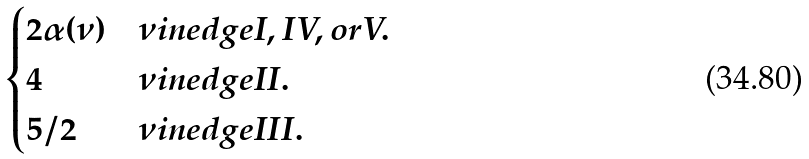Convert formula to latex. <formula><loc_0><loc_0><loc_500><loc_500>\begin{cases} 2 \alpha ( \nu ) & \nu i n e d g e I , I V , o r V . \\ 4 & \nu i n e d g e I I . \\ 5 / 2 & \nu i n e d g e I I I . \end{cases}</formula> 